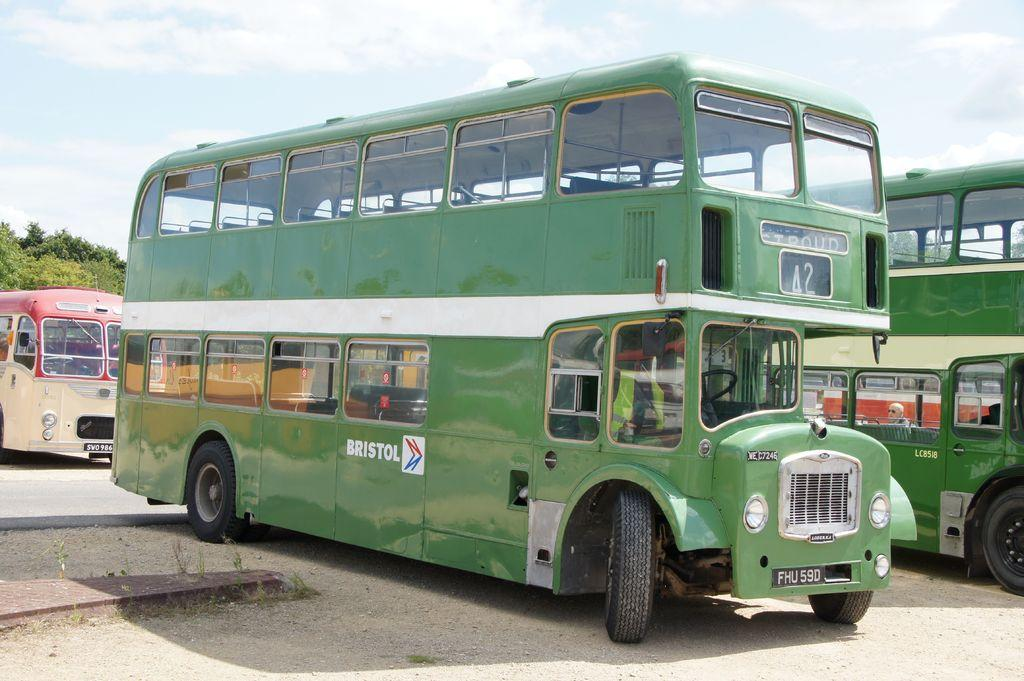<image>
Give a short and clear explanation of the subsequent image. a two doubledecker bus from Bristol parked outside 